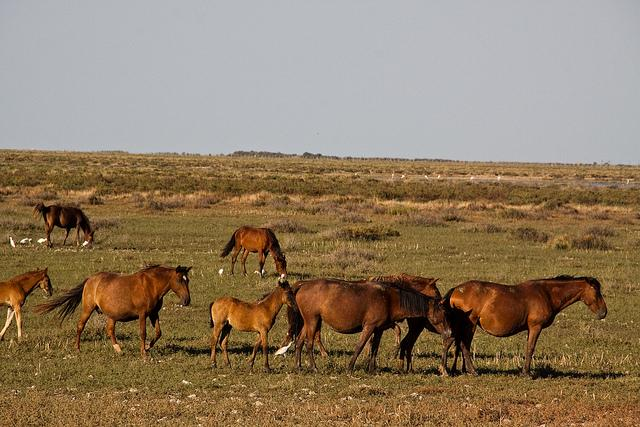What type of land are the horses found on? prairie 